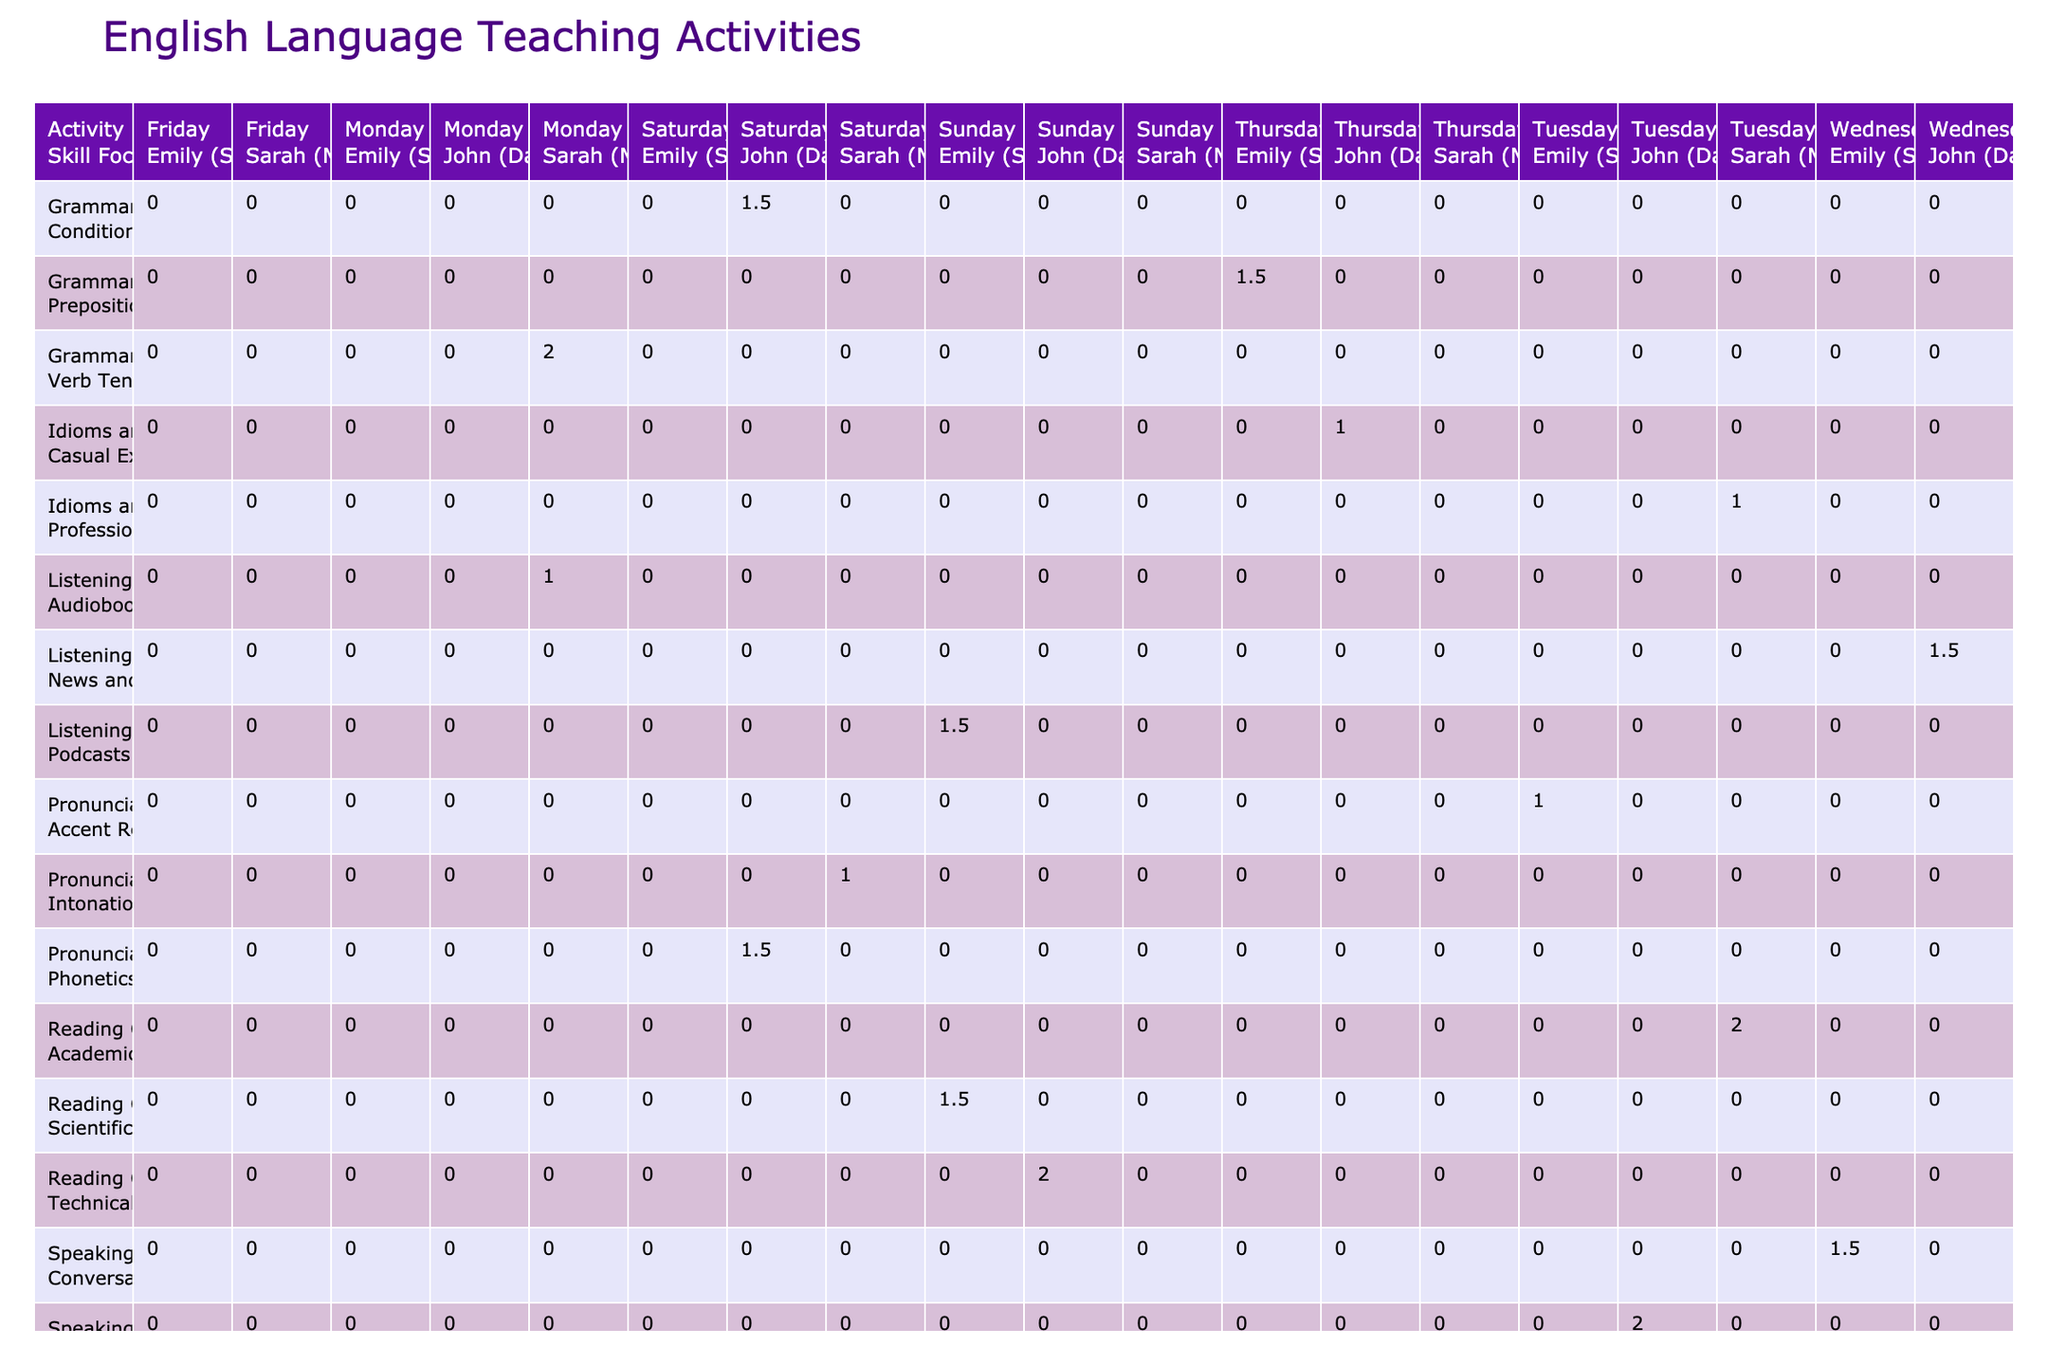What is the total number of hours allocated for Grammar Lessons on weekdays? According to the table, Grammar Lessons are taught on Monday (2 hours), Wednesday (1.5 hours), and Thursday (1.5 hours). To find the total, we add these values: 2 + 1.5 + 1.5 = 5 hours.
Answer: 5 hours Which student receives the most hours of instruction in Vocabulary Building? In the table, Vocabulary Building appears on Monday with John (Dad) receiving 1.5 hours, and on Saturday with Emily (Sister) and Sarah (Mom) receiving 1 hour each. Therefore, John (Dad) has the highest total hours for Vocabulary Building with 1.5 hours.
Answer: John (Dad) Did Sarah (Mom) participate in any Listening Exercises? Yes, according to the table, Sarah (Mom) participated in Listening Exercises on Monday for 1 hour.
Answer: Yes Which activity has the highest total hours allocated for Sarah (Mom)? By examining the table, we can see that Sarah (Mom) has the following hours: Grammar Lessons (2 hours), Reading Comprehension (2 hours), Writing Workshop (2 hours), and Pronunciation Practice (1 hour). The total for all activities is 2 + 2 + 2 + 1 = 7 hours. The activities with the highest individual hours (2 hours each) are Grammar Lessons, Reading Comprehension, and Writing Workshop.
Answer: 7 hours What is the difference in total instruction hours between John (Dad) and Emily (Sister)? To find the total hours for John (Dad), we add his hours: Vocabulary Building (1.5) + Listening Exercises (1.5) + Test Preparation (2) + Grammar Lessons (1.5) for a total of 6.5 hours. For Emily (Sister), we have: Pronunciation Practice (1) + Reading Comprehension (2) + Test Preparation (2) + Writing Workshop (1.5) + Vocabulary Building (1) + Listening Exercises (1.5) for a total of 9 hours. The difference is 9 - 6.5 = 2.5 hours.
Answer: 2.5 hours 